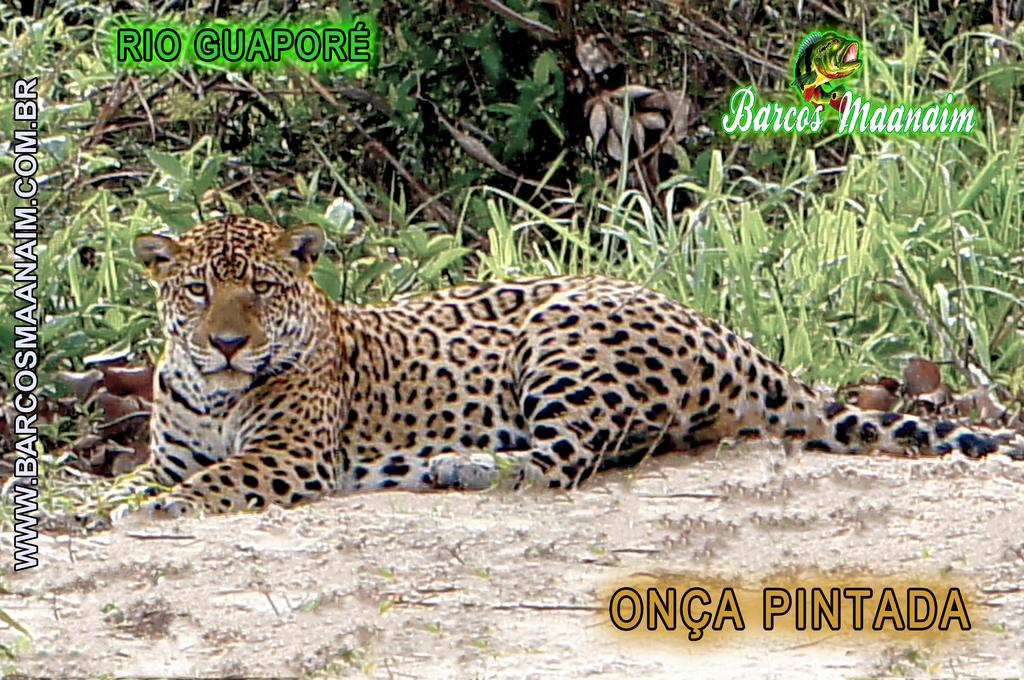How has the image been altered? The image has been edited. What else can be found in the image besides the edited content? There is text and an animal sitting on the ground in the image. What type of vegetation is present in the image? There are plants in the image. What type of dirt can be seen on the animal's fur in the image? There is no dirt visible on the animal's fur in the image. What type of marble is present in the image? There is no marble present in the image. 